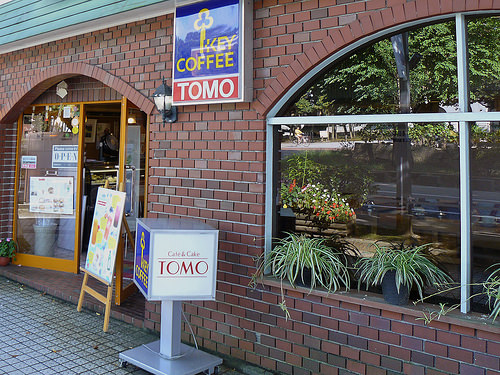<image>
Is the wall under the window? No. The wall is not positioned under the window. The vertical relationship between these objects is different. 